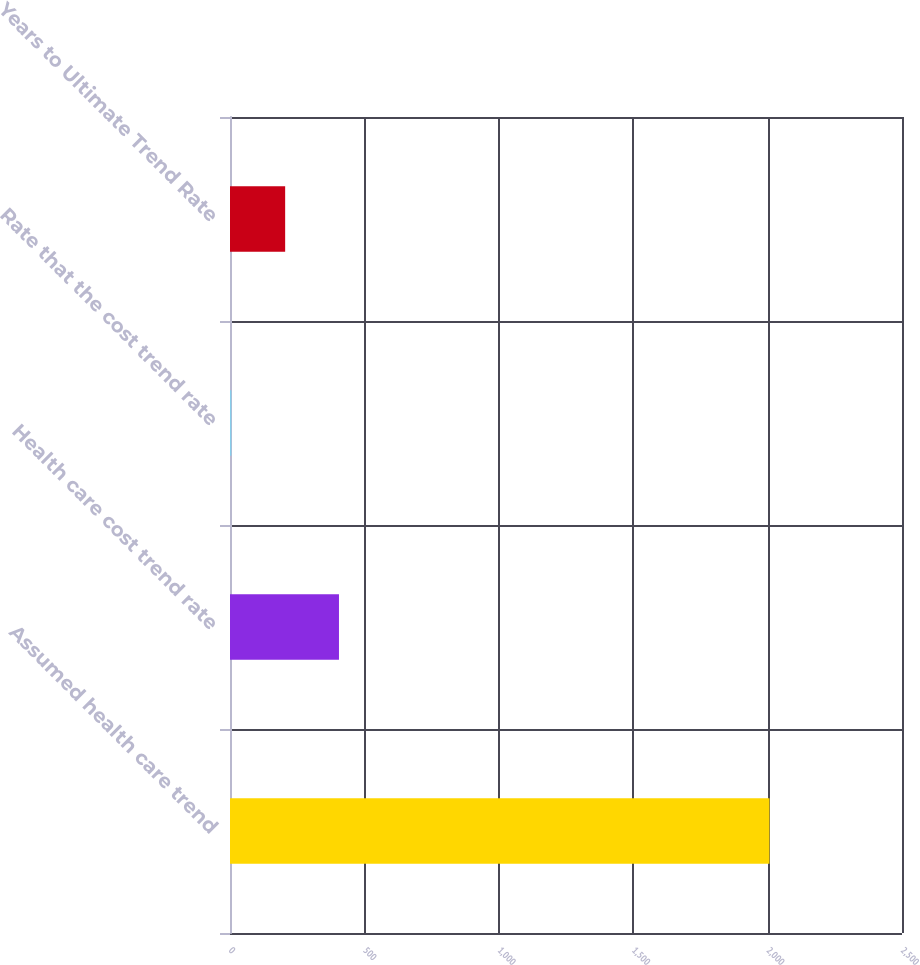Convert chart. <chart><loc_0><loc_0><loc_500><loc_500><bar_chart><fcel>Assumed health care trend<fcel>Health care cost trend rate<fcel>Rate that the cost trend rate<fcel>Years to Ultimate Trend Rate<nl><fcel>2007<fcel>405.4<fcel>5<fcel>205.2<nl></chart> 